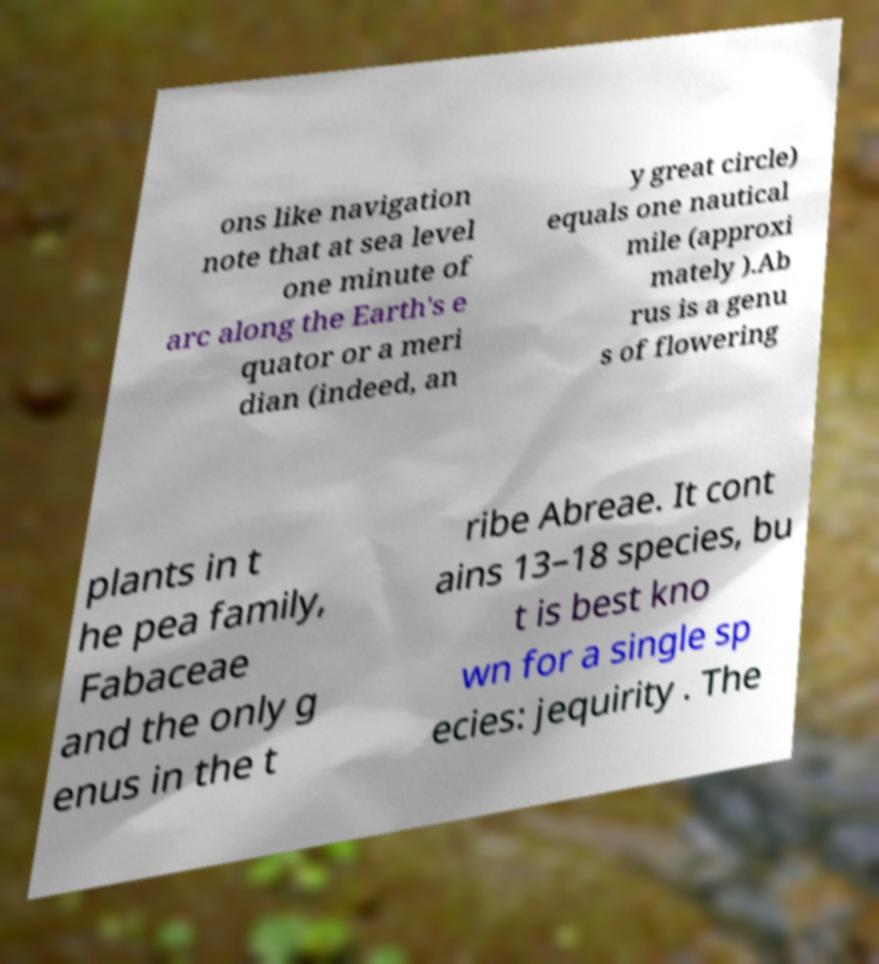Please read and relay the text visible in this image. What does it say? ons like navigation note that at sea level one minute of arc along the Earth's e quator or a meri dian (indeed, an y great circle) equals one nautical mile (approxi mately ).Ab rus is a genu s of flowering plants in t he pea family, Fabaceae and the only g enus in the t ribe Abreae. It cont ains 13–18 species, bu t is best kno wn for a single sp ecies: jequirity . The 